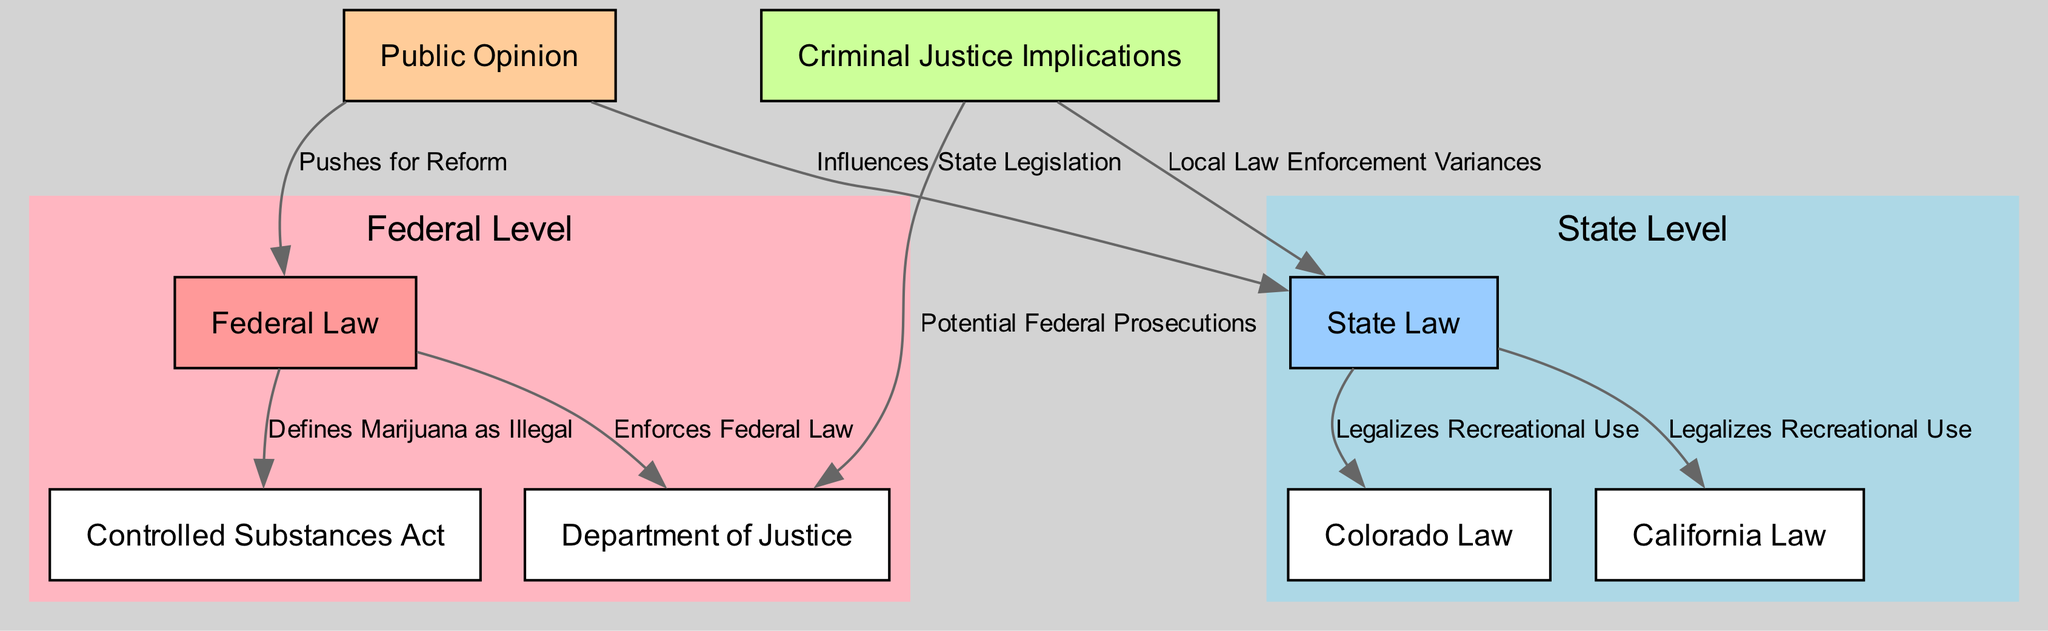What defines marijuana as illegal at the federal level? The diagram indicates that the Controlled Substances Act, which is part of federal law, defines marijuana as illegal.
Answer: Controlled Substances Act What laws legalize recreational marijuana use? The diagram shows that both Colorado Law and California Law legalize recreational marijuana use at the state level.
Answer: Colorado Law, California Law How many edges are in the diagram? By counting the edges in the diagram, there are a total of eight edges that represent relationships between nodes.
Answer: 8 What influences state legislation regarding marijuana? The diagram illustrates that public opinion influences state law, which affects marijuana legislation.
Answer: Public Opinion What is one potential implication for criminal justice due to marijuana legalization? The diagram points out potential federal prosecutions as a significant implication for criminal justice given the conflict between federal and state laws.
Answer: Potential Federal Prosecutions What is the relationship between public opinion and federal law? The diagram illustrates that public opinion pushes for reform in federal law related to marijuana legalization.
Answer: Pushes for Reform Which department is responsible for enforcing federal marijuana laws? According to the diagram, the Department of Justice is responsible for enforcing federal law concerning marijuana.
Answer: Department of Justice What are local law enforcement variances associated with? The diagram shows that local law enforcement variances are linked to the state law regarding marijuana legalization, highlighting differences in enforcement practices.
Answer: State Law 